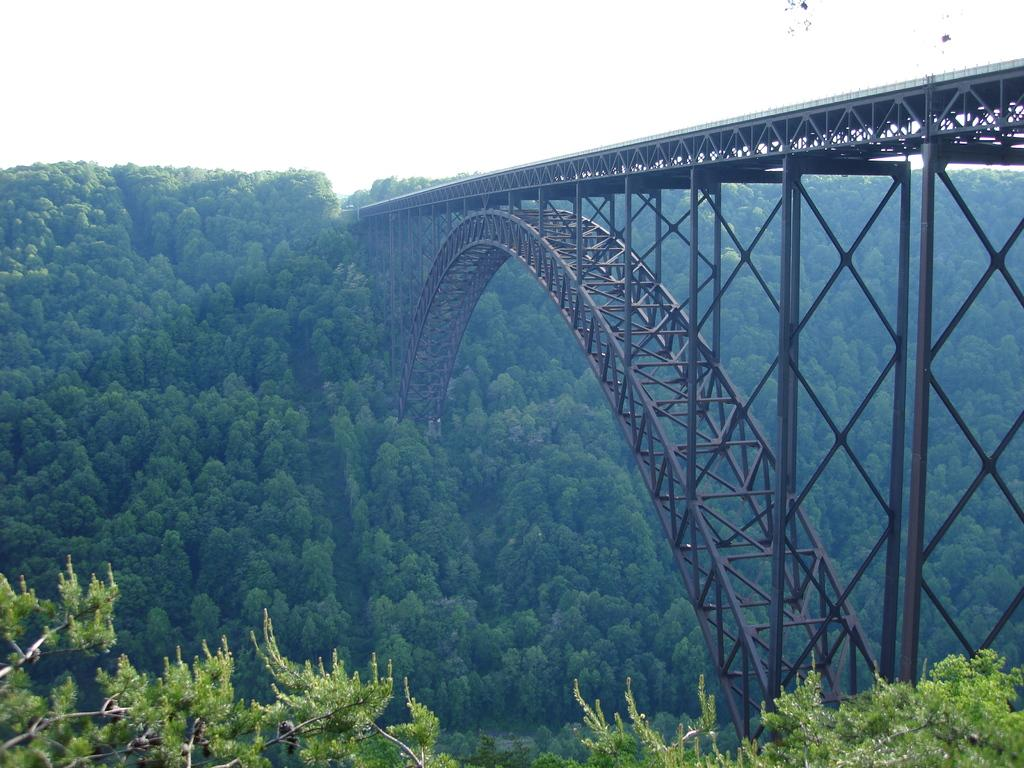What can be seen in the foreground of the picture? There are trees in the foreground of the picture. What is the main structure in the center of the picture? There is a bridge in the center of the picture. What is visible in the background of the picture? There are trees in the background of the picture. How many pans can be seen hanging from the bridge in the image? There are no pans visible in the image; the focus is on the trees and the bridge. What type of lizards can be seen crawling on the trees in the background? There are no lizards present in the image; only trees are visible in the background. 